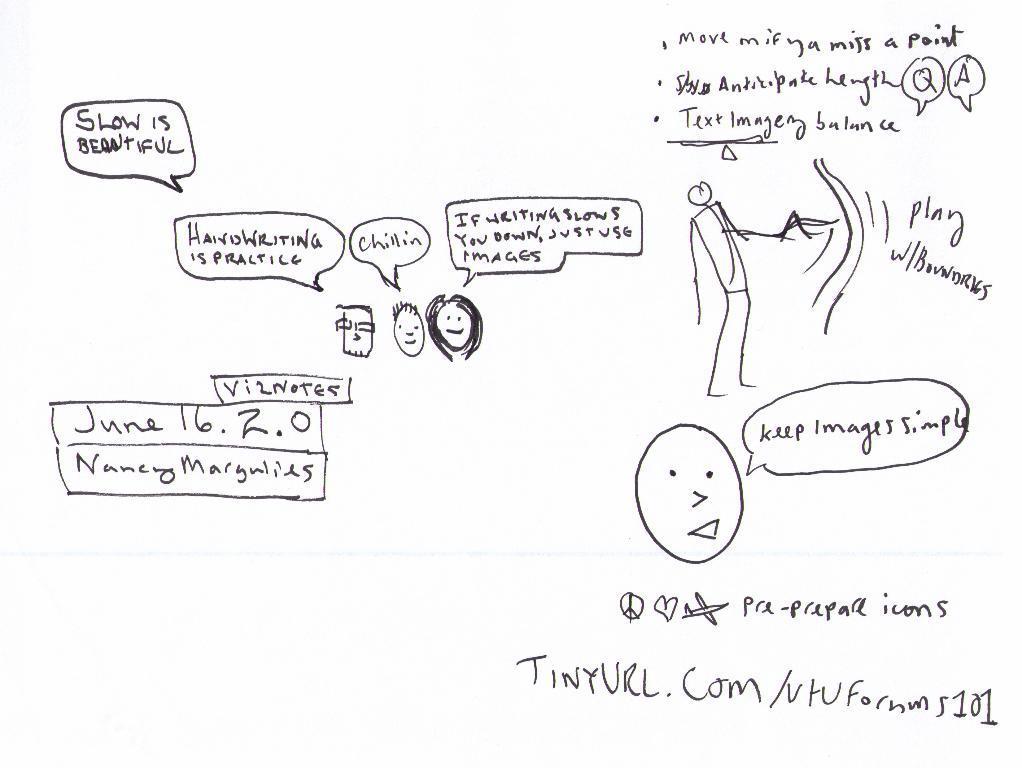Could you give a brief overview of what you see in this image? In this picture we can see a paper, there is some handwritten text and sketches on this paper. 